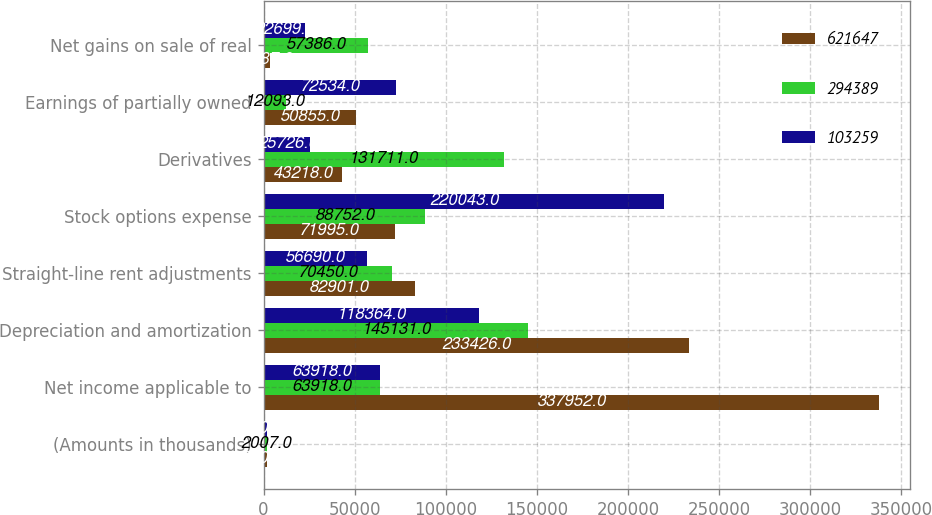Convert chart. <chart><loc_0><loc_0><loc_500><loc_500><stacked_bar_chart><ecel><fcel>(Amounts in thousands)<fcel>Net income applicable to<fcel>Depreciation and amortization<fcel>Straight-line rent adjustments<fcel>Stock options expense<fcel>Derivatives<fcel>Earnings of partially owned<fcel>Net gains on sale of real<nl><fcel>621647<fcel>2008<fcel>337952<fcel>233426<fcel>82901<fcel>71995<fcel>43218<fcel>50855<fcel>3687<nl><fcel>294389<fcel>2007<fcel>63918<fcel>145131<fcel>70450<fcel>88752<fcel>131711<fcel>12093<fcel>57386<nl><fcel>103259<fcel>2006<fcel>63918<fcel>118364<fcel>56690<fcel>220043<fcel>25726<fcel>72534<fcel>22699<nl></chart> 